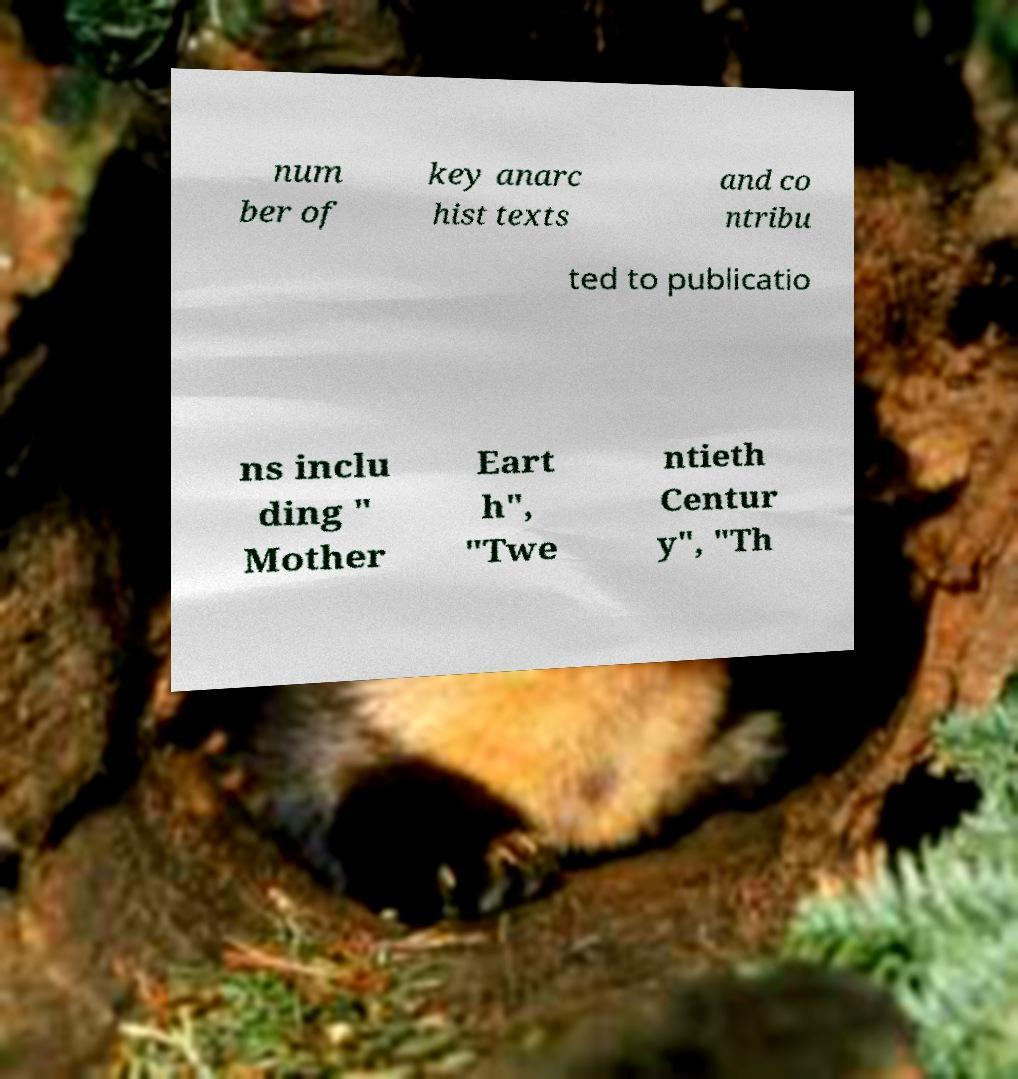Please identify and transcribe the text found in this image. num ber of key anarc hist texts and co ntribu ted to publicatio ns inclu ding " Mother Eart h", "Twe ntieth Centur y", "Th 